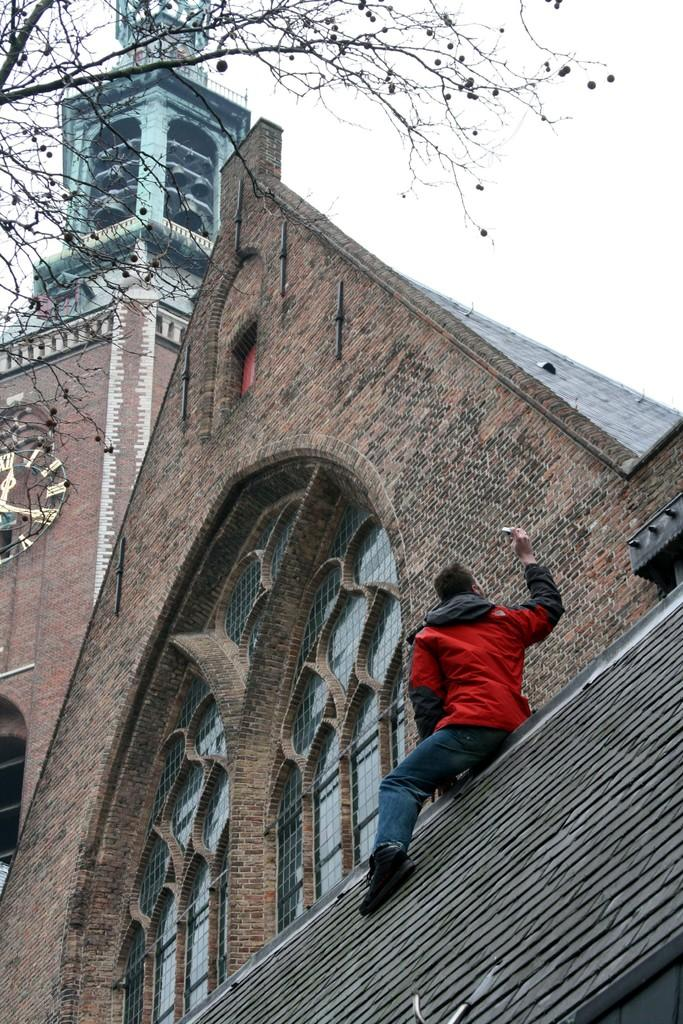What is the person in the image doing? There is a person sitting on the surface in the image. What can be seen behind the person? There is a wall in the image. Is there any opening in the wall? Yes, there is a window in the image. What is visible outside the window? There is a tree in the image. What is in the background of the image? There is a building in the background of the image, and the sky is visible as well. Can you describe any details on the building? There is a clock on the building. What type of shirt is the rat wearing in the image? There is no rat present in the image, and therefore no shirt or any clothing can be observed. 